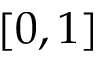<formula> <loc_0><loc_0><loc_500><loc_500>[ 0 , 1 ]</formula> 